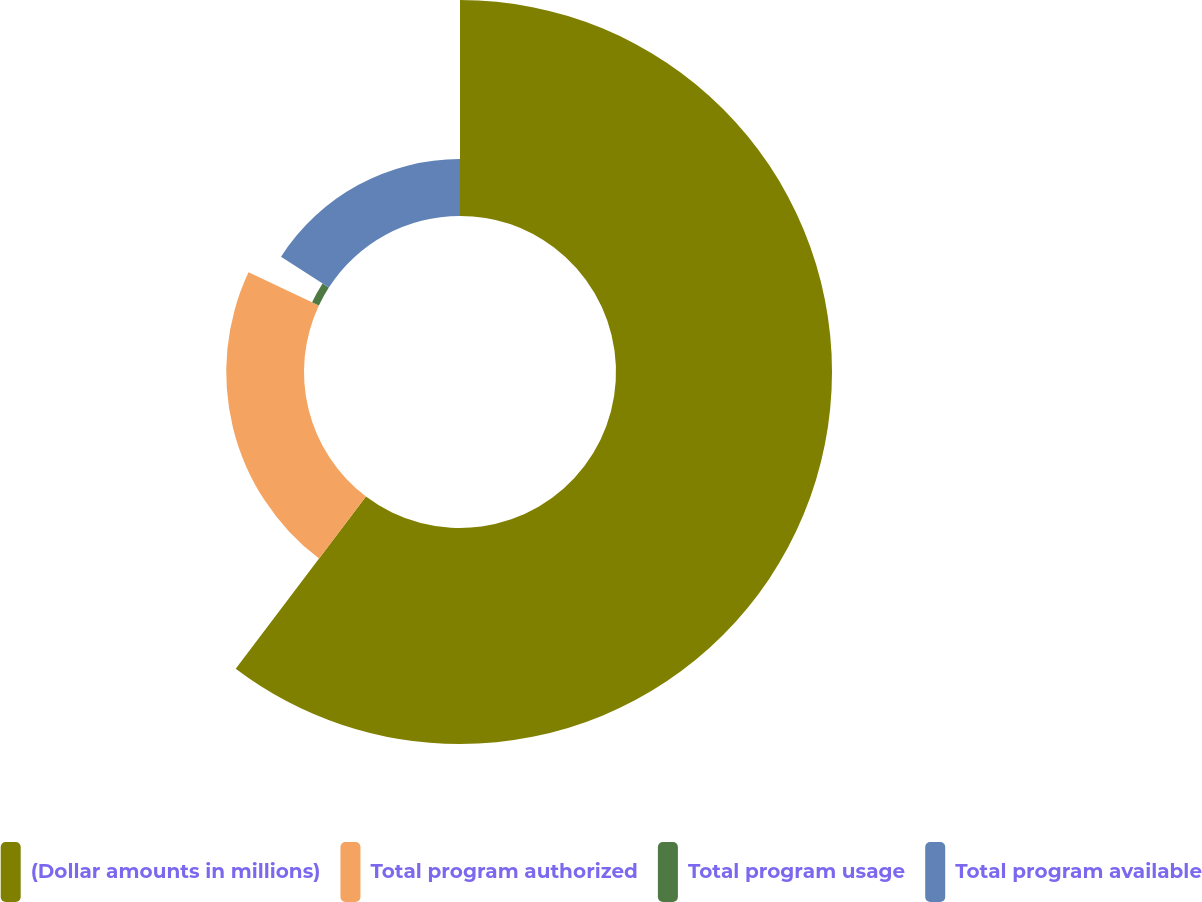<chart> <loc_0><loc_0><loc_500><loc_500><pie_chart><fcel>(Dollar amounts in millions)<fcel>Total program authorized<fcel>Total program usage<fcel>Total program available<nl><fcel>60.3%<fcel>21.71%<fcel>2.1%<fcel>15.89%<nl></chart> 